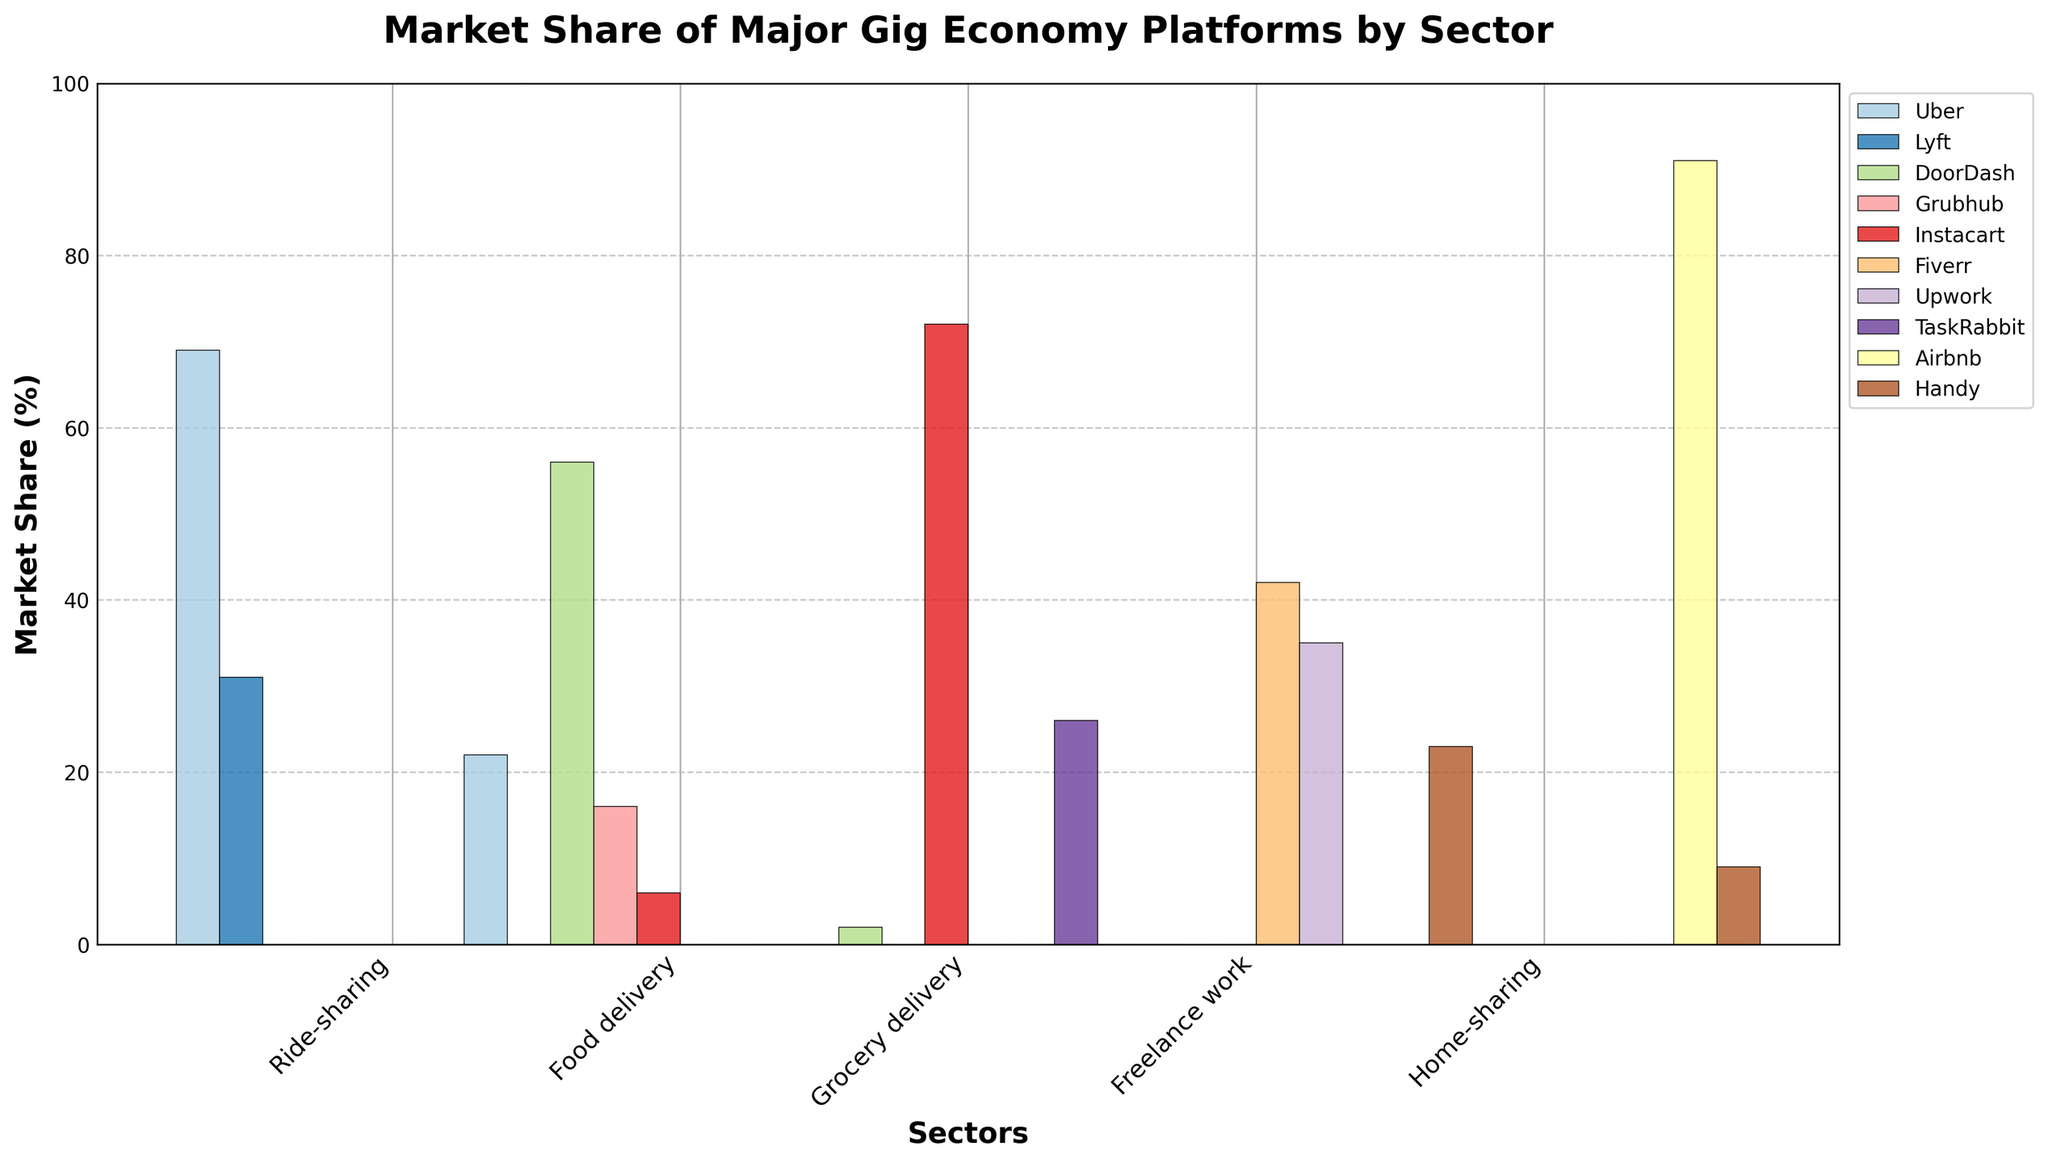Which sector does Uber dominate in terms of market share? By observing the bars in the ride-sharing sector where Uber has the highest value among its competitors (69%), it indicates dominance.
Answer: Ride-sharing Which platform has the second-largest market share in the Food delivery sector? The bars for the Food delivery sector show the following values: DoorDash (56%), Grubhub (16%), and Instacart (6%). The second-largest market share is for Grubhub.
Answer: Grubhub Among gig economy platforms in the Freelance work sector, what is the combined market share of Fiverr and Upwork? In the Freelance work sector, the market shares are Fiverr (42%) and Upwork (35%). Adding these percentages together gives 42 + 35 = 77.
Answer: 77% Which sector is dominated by Airbnb in the gig economy? By checking the sectors, Airbnb has its highest bar in the Home-sharing sector with 91%, indicating dominance.
Answer: Home-sharing Compare the market share of TaskRabbit and Handy in the Grocery delivery sector. Which one is higher? In Grocery delivery, TaskRabbit has a market share of 26%, and Handy has 0%. TaskRabbit's share is higher.
Answer: TaskRabbit What is the difference in market share between Uber and Lyft in the Ride-sharing sector? The Ride-sharing sector shows Uber with 69% and Lyft with 31%. Calculating the difference: 69 - 31 = 38.
Answer: 38% In the Home-sharing sector, what is the ratio of Airbnb's market share to Handy's market share? In the Home-sharing sector, Airbnb's share is 91% while Handy's is 9%. The ratio is thus 91:9, which simplifies to 10.1:1.
Answer: 10.1:1 What is the average market share of the platforms involved in the Food delivery sector? The shares are DoorDash (56%), Grubhub (16%), and Instacart (6%). Average is calculated as (56 + 16 + 6) / 3 = 26%.
Answer: 26% Which sector shows a zero market share for platforms Fiverr and Upwork? Fiverr and Upwork display zero market shares in all sectors except Freelance work. Ride-sharing, Food delivery, Grocery delivery, and Home-sharing all show zero shares for both.
Answer: Ride-sharing, Food delivery, Grocery delivery, Home-sharing In the Grocery delivery sector, which platform has the highest market share and what is it? In the Grocery delivery sector, Instacart has the highest market share with a value of 72%.
Answer: Instacart, 72% 